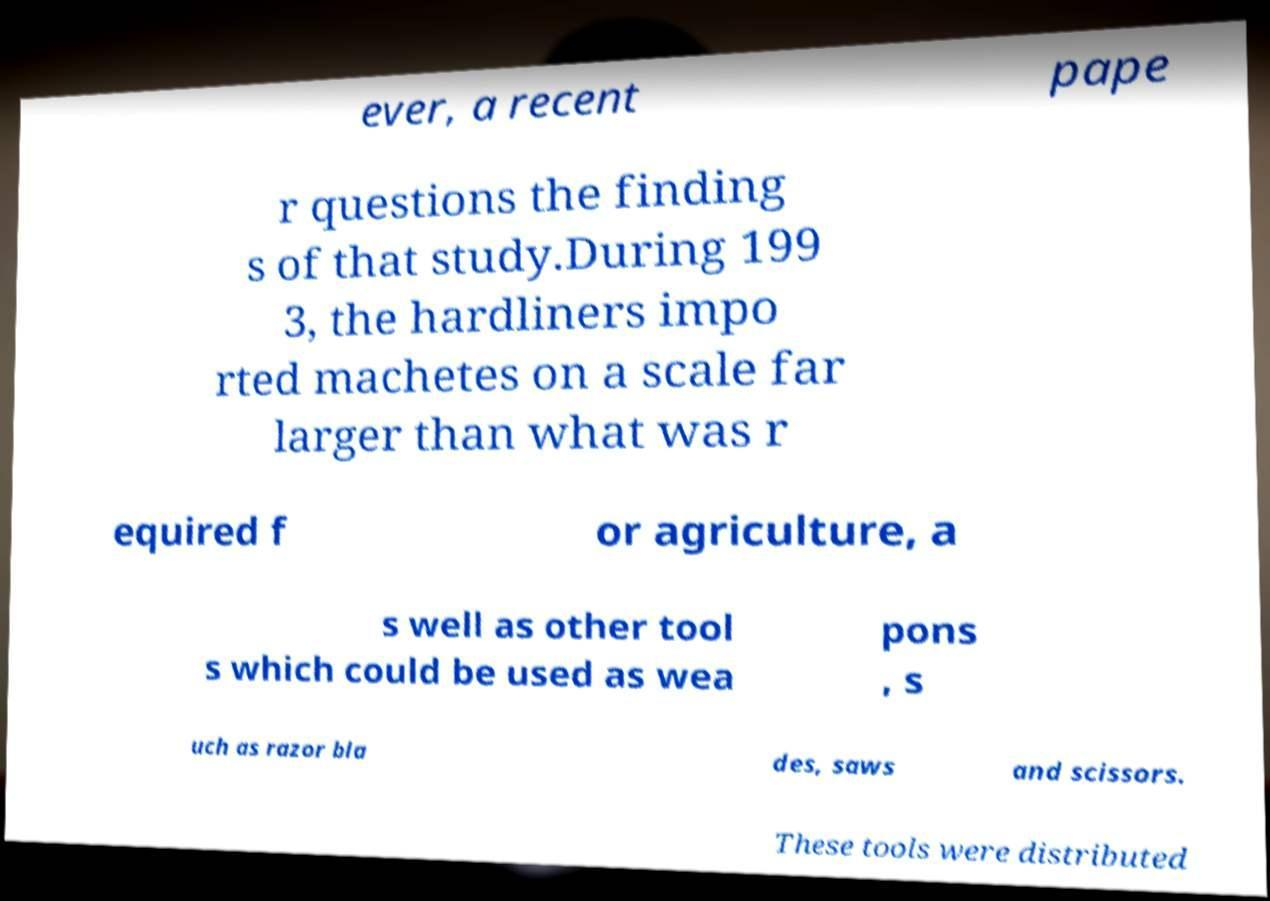Please identify and transcribe the text found in this image. ever, a recent pape r questions the finding s of that study.During 199 3, the hardliners impo rted machetes on a scale far larger than what was r equired f or agriculture, a s well as other tool s which could be used as wea pons , s uch as razor bla des, saws and scissors. These tools were distributed 